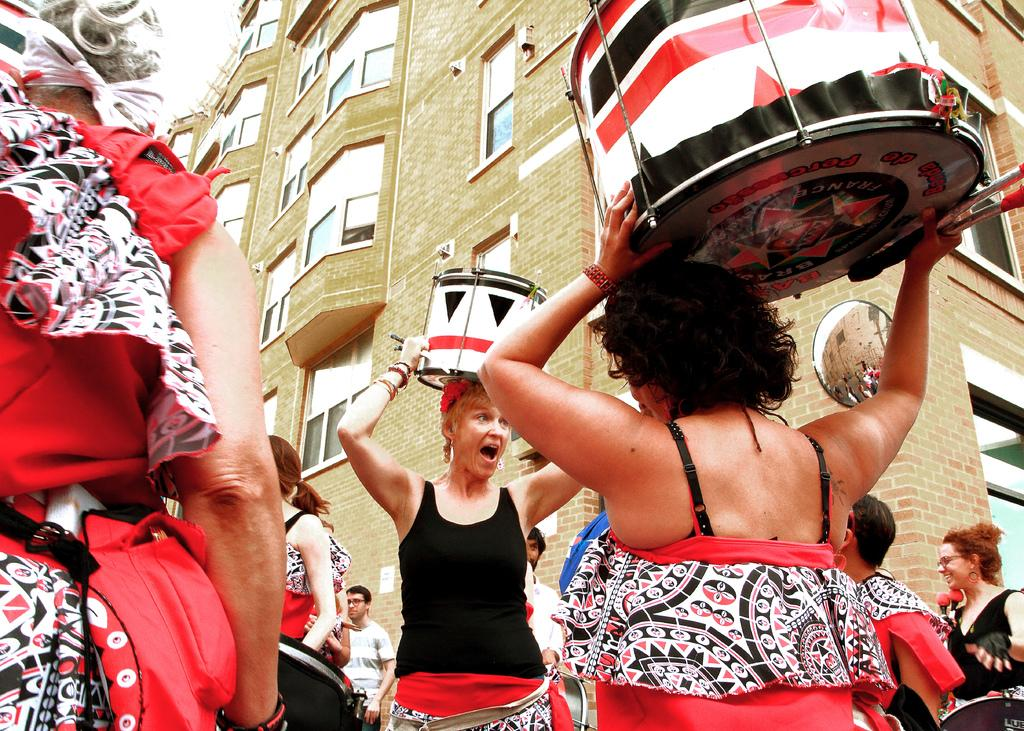What color are the dresses worn by the people in the image? The people in the image are wearing red color dresses. What are the women holding in their hands? Two women are holding drums in their hands. What can be seen in the background of the image? There is a building in the background of the image. What type of box is being used as a stage for the performance in the image? There is no box present in the image; it features people wearing red color dresses and women holding drums. Is there a tent visible in the image? No, there is no tent present in the image. 